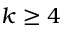Convert formula to latex. <formula><loc_0><loc_0><loc_500><loc_500>k \geq 4</formula> 